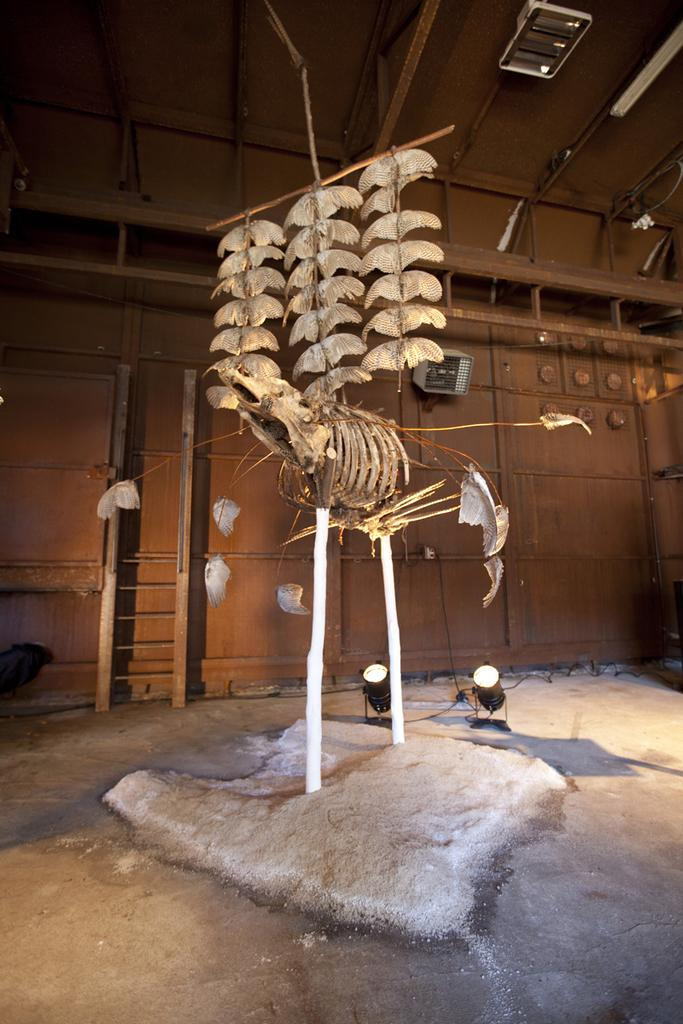What can be seen in the image that is related to ancient life? There are fossils in the image. What is visible in the background of the image? There is a wall in the background of the image. What can be seen providing illumination in the image? There are lights visible in the image. What type of toothbrush is being used to clean the fossils in the image? There is no toothbrush present in the image, and the text does not mention any cleaning activity. 